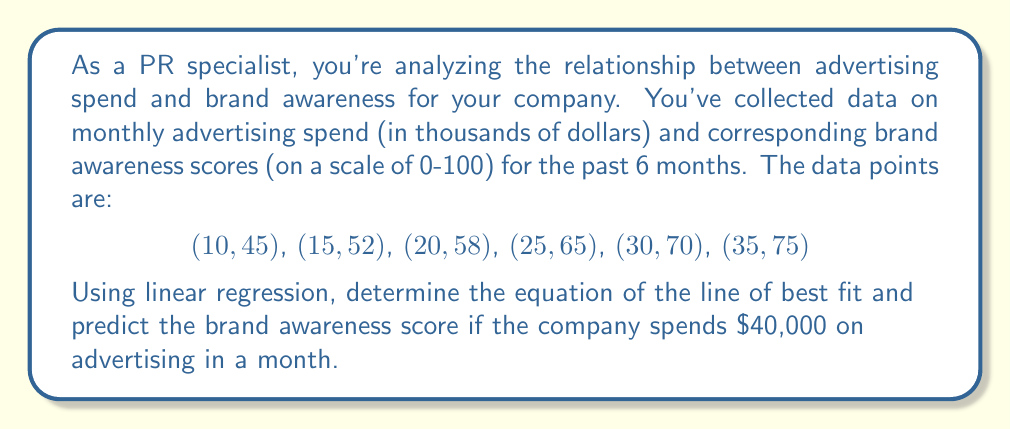Solve this math problem. To solve this problem, we'll use linear regression to find the line of best fit and then use that equation to predict the brand awareness score.

Step 1: Calculate the means of x (advertising spend) and y (brand awareness):
$\bar{x} = \frac{10 + 15 + 20 + 25 + 30 + 35}{6} = 22.5$
$\bar{y} = \frac{45 + 52 + 58 + 65 + 70 + 75}{6} = 60.83$

Step 2: Calculate the slope (m) using the formula:
$$m = \frac{\sum(x_i - \bar{x})(y_i - \bar{y})}{\sum(x_i - \bar{x})^2}$$

$\sum(x_i - \bar{x})(y_i - \bar{y}) = 462.5$
$\sum(x_i - \bar{x})^2 = 312.5$

$m = \frac{462.5}{312.5} = 1.48$

Step 3: Calculate the y-intercept (b) using the formula:
$b = \bar{y} - m\bar{x}$
$b = 60.83 - 1.48(22.5) = 27.53$

Step 4: Write the equation of the line of best fit:
$y = 1.48x + 27.53$

Step 5: Predict the brand awareness score for $40,000 advertising spend:
$y = 1.48(40) + 27.53 = 86.73$

Therefore, the predicted brand awareness score for a $40,000 advertising spend is approximately 86.73.
Answer: $y = 1.48x + 27.53$; Brand awareness score for $40,000 spend: 86.73 